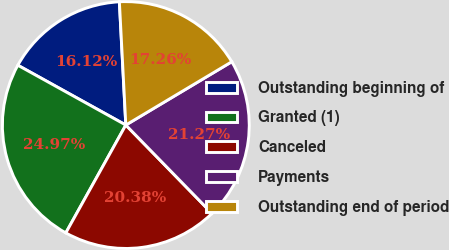Convert chart. <chart><loc_0><loc_0><loc_500><loc_500><pie_chart><fcel>Outstanding beginning of<fcel>Granted (1)<fcel>Canceled<fcel>Payments<fcel>Outstanding end of period<nl><fcel>16.12%<fcel>24.97%<fcel>20.38%<fcel>21.27%<fcel>17.26%<nl></chart> 